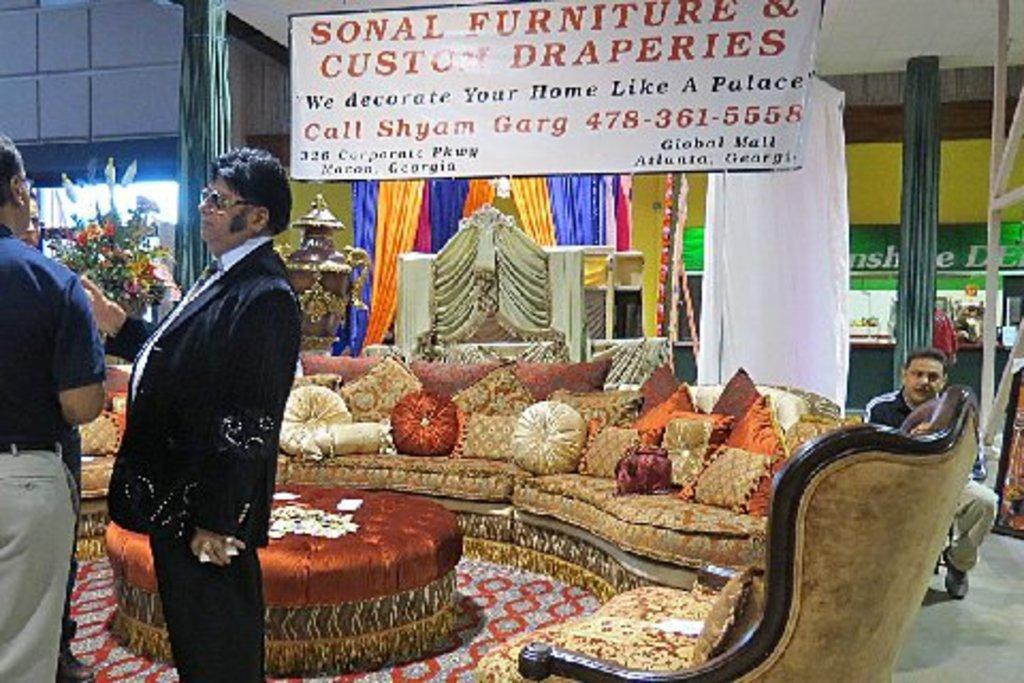What is the main piece of furniture in the center of the image? There is a sofa in the center of the image. What are the people in the image doing? The two people are standing on the left side of the image. What can be seen in the background of the image? There are curtains, pillars, doors, and decorations in the background of the image. What is visible at the top of the image? There is a board visible at the top of the image. How many thumbs can be seen on the people in the image? There is no information about the number of thumbs visible on the people in the image. Does the existence of the sofa in the image prove the existence of life on other planets? The presence of a sofa in the image does not provide any information about the existence of life on other planets. 